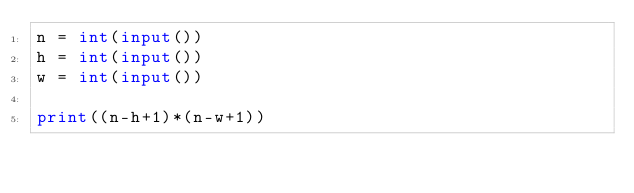<code> <loc_0><loc_0><loc_500><loc_500><_Python_>n = int(input())
h = int(input())
w = int(input())

print((n-h+1)*(n-w+1))</code> 